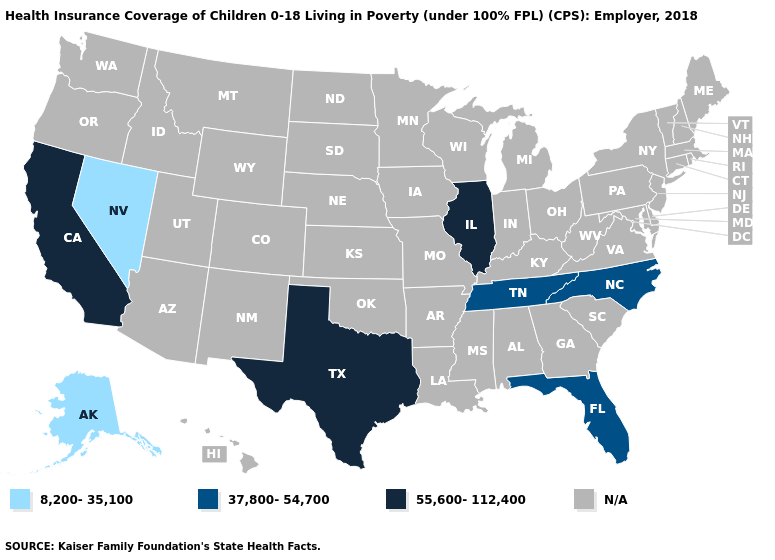What is the highest value in the USA?
Answer briefly. 55,600-112,400. How many symbols are there in the legend?
Concise answer only. 4. Does Florida have the lowest value in the USA?
Short answer required. No. What is the value of Alabama?
Keep it brief. N/A. What is the value of Wisconsin?
Concise answer only. N/A. Among the states that border North Carolina , which have the lowest value?
Short answer required. Tennessee. Name the states that have a value in the range 55,600-112,400?
Give a very brief answer. California, Illinois, Texas. Which states have the lowest value in the USA?
Write a very short answer. Alaska, Nevada. What is the value of Virginia?
Quick response, please. N/A. What is the value of Hawaii?
Concise answer only. N/A. 